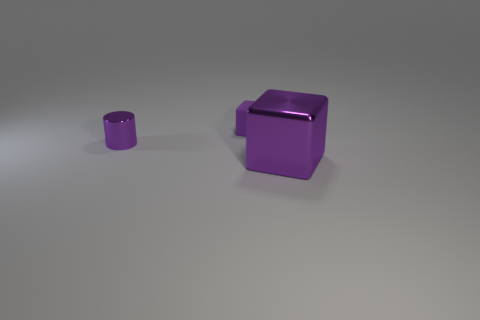Add 1 small blue rubber objects. How many objects exist? 4 Subtract all blocks. How many objects are left? 1 Add 2 cubes. How many cubes are left? 4 Add 2 big objects. How many big objects exist? 3 Subtract 0 red spheres. How many objects are left? 3 Subtract all tiny purple shiny objects. Subtract all large cubes. How many objects are left? 1 